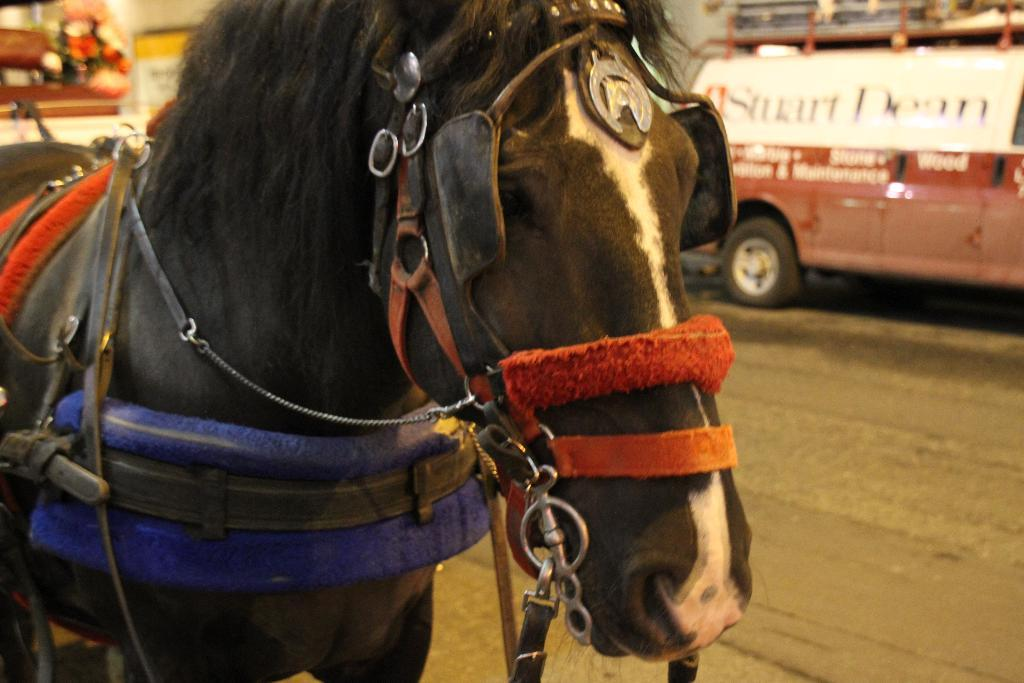What animal is present in the image? There is a horse in the image. What type of equipment is on the horse's head? The horse has a rope halter. What else can be seen in the image besides the horse? There is a vehicle on the road in the image. What design can be seen on the wax balls in the image? There are no wax balls present in the image. 